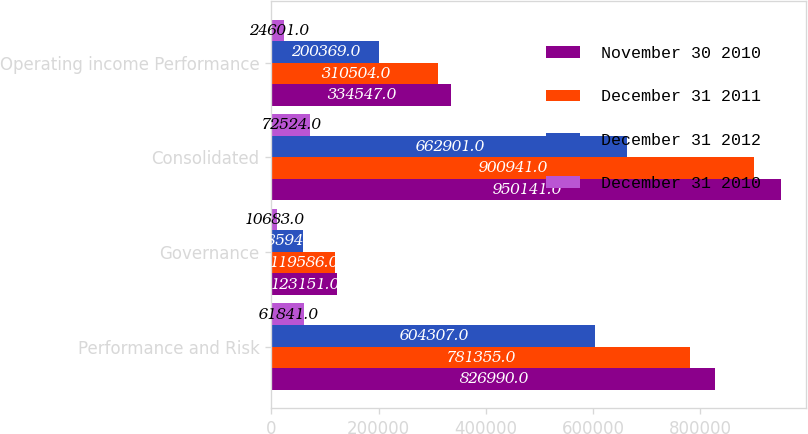Convert chart. <chart><loc_0><loc_0><loc_500><loc_500><stacked_bar_chart><ecel><fcel>Performance and Risk<fcel>Governance<fcel>Consolidated<fcel>Operating income Performance<nl><fcel>November 30 2010<fcel>826990<fcel>123151<fcel>950141<fcel>334547<nl><fcel>December 31 2011<fcel>781355<fcel>119586<fcel>900941<fcel>310504<nl><fcel>December 31 2012<fcel>604307<fcel>58594<fcel>662901<fcel>200369<nl><fcel>December 31 2010<fcel>61841<fcel>10683<fcel>72524<fcel>24601<nl></chart> 